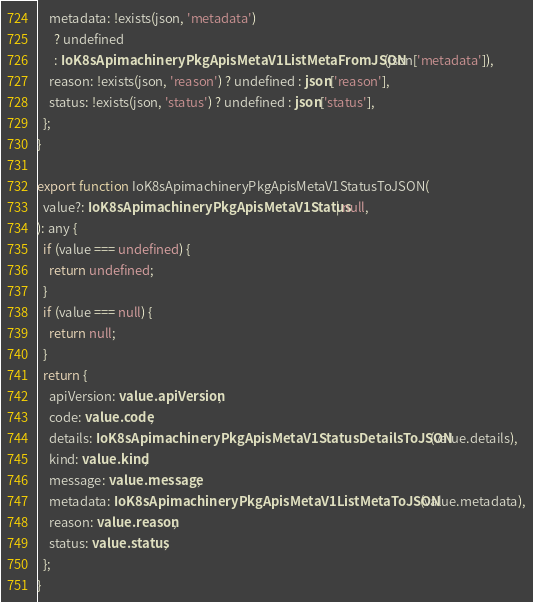Convert code to text. <code><loc_0><loc_0><loc_500><loc_500><_TypeScript_>    metadata: !exists(json, 'metadata')
      ? undefined
      : IoK8sApimachineryPkgApisMetaV1ListMetaFromJSON(json['metadata']),
    reason: !exists(json, 'reason') ? undefined : json['reason'],
    status: !exists(json, 'status') ? undefined : json['status'],
  };
}

export function IoK8sApimachineryPkgApisMetaV1StatusToJSON(
  value?: IoK8sApimachineryPkgApisMetaV1Status | null,
): any {
  if (value === undefined) {
    return undefined;
  }
  if (value === null) {
    return null;
  }
  return {
    apiVersion: value.apiVersion,
    code: value.code,
    details: IoK8sApimachineryPkgApisMetaV1StatusDetailsToJSON(value.details),
    kind: value.kind,
    message: value.message,
    metadata: IoK8sApimachineryPkgApisMetaV1ListMetaToJSON(value.metadata),
    reason: value.reason,
    status: value.status,
  };
}
</code> 